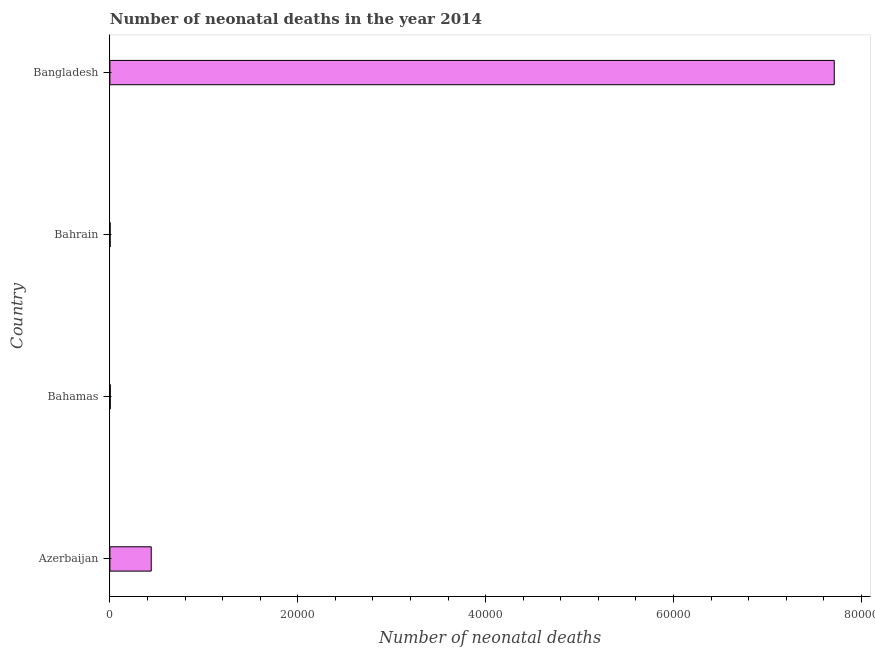What is the title of the graph?
Make the answer very short. Number of neonatal deaths in the year 2014. What is the label or title of the X-axis?
Offer a terse response. Number of neonatal deaths. What is the number of neonatal deaths in Bangladesh?
Your answer should be very brief. 7.71e+04. Across all countries, what is the maximum number of neonatal deaths?
Your response must be concise. 7.71e+04. In which country was the number of neonatal deaths minimum?
Keep it short and to the point. Bahrain. What is the sum of the number of neonatal deaths?
Your answer should be compact. 8.16e+04. What is the difference between the number of neonatal deaths in Bahamas and Bangladesh?
Give a very brief answer. -7.71e+04. What is the average number of neonatal deaths per country?
Give a very brief answer. 2.04e+04. What is the median number of neonatal deaths?
Give a very brief answer. 2221.5. What is the ratio of the number of neonatal deaths in Bahamas to that in Bahrain?
Give a very brief answer. 1.75. Is the number of neonatal deaths in Azerbaijan less than that in Bangladesh?
Your answer should be very brief. Yes. What is the difference between the highest and the second highest number of neonatal deaths?
Provide a short and direct response. 7.27e+04. What is the difference between the highest and the lowest number of neonatal deaths?
Provide a short and direct response. 7.71e+04. Are all the bars in the graph horizontal?
Give a very brief answer. Yes. How many countries are there in the graph?
Make the answer very short. 4. What is the Number of neonatal deaths of Azerbaijan?
Your response must be concise. 4401. What is the Number of neonatal deaths in Bahamas?
Offer a terse response. 42. What is the Number of neonatal deaths of Bangladesh?
Give a very brief answer. 7.71e+04. What is the difference between the Number of neonatal deaths in Azerbaijan and Bahamas?
Offer a very short reply. 4359. What is the difference between the Number of neonatal deaths in Azerbaijan and Bahrain?
Your answer should be very brief. 4377. What is the difference between the Number of neonatal deaths in Azerbaijan and Bangladesh?
Keep it short and to the point. -7.27e+04. What is the difference between the Number of neonatal deaths in Bahamas and Bahrain?
Offer a terse response. 18. What is the difference between the Number of neonatal deaths in Bahamas and Bangladesh?
Keep it short and to the point. -7.71e+04. What is the difference between the Number of neonatal deaths in Bahrain and Bangladesh?
Your response must be concise. -7.71e+04. What is the ratio of the Number of neonatal deaths in Azerbaijan to that in Bahamas?
Provide a succinct answer. 104.79. What is the ratio of the Number of neonatal deaths in Azerbaijan to that in Bahrain?
Provide a short and direct response. 183.38. What is the ratio of the Number of neonatal deaths in Azerbaijan to that in Bangladesh?
Keep it short and to the point. 0.06. What is the ratio of the Number of neonatal deaths in Bahamas to that in Bahrain?
Offer a very short reply. 1.75. What is the ratio of the Number of neonatal deaths in Bahrain to that in Bangladesh?
Your answer should be compact. 0. 